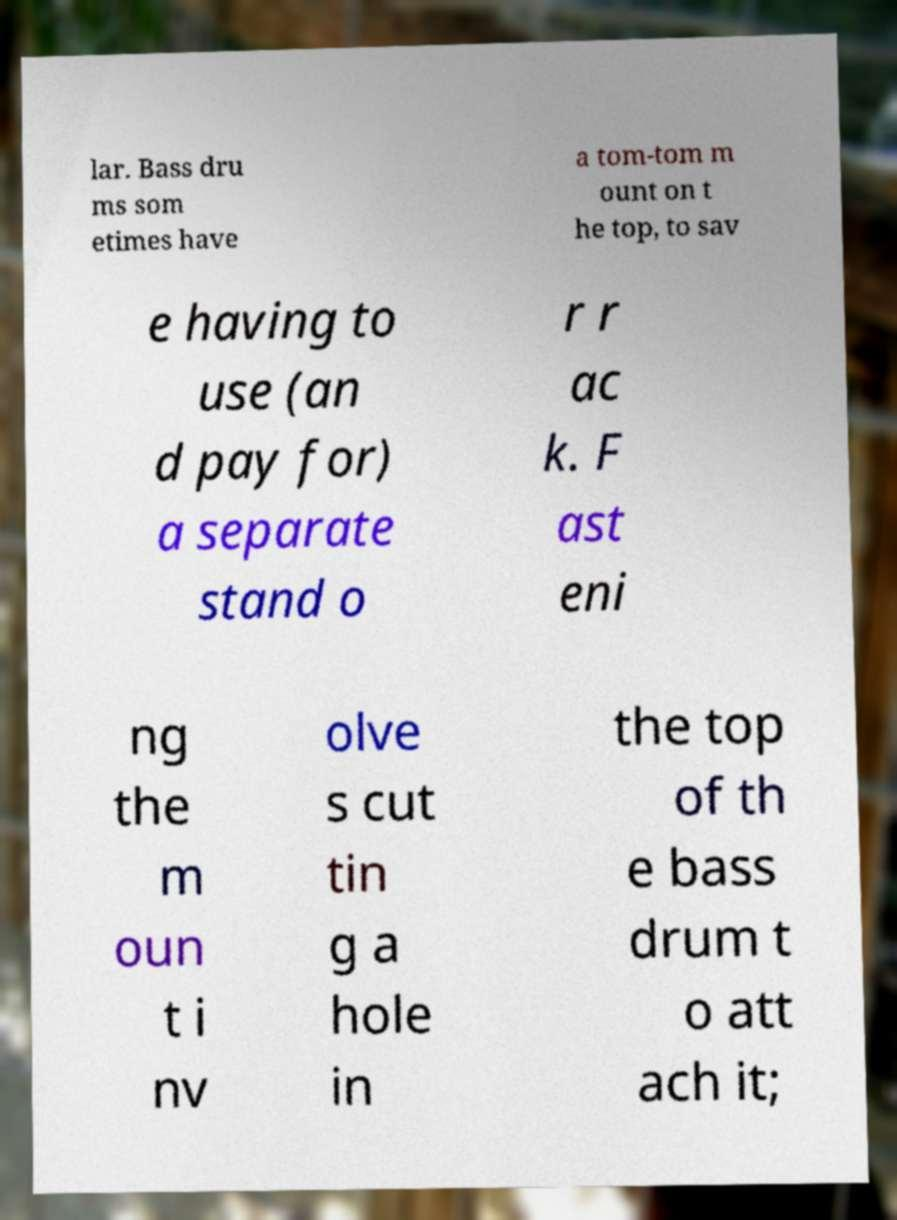What messages or text are displayed in this image? I need them in a readable, typed format. lar. Bass dru ms som etimes have a tom-tom m ount on t he top, to sav e having to use (an d pay for) a separate stand o r r ac k. F ast eni ng the m oun t i nv olve s cut tin g a hole in the top of th e bass drum t o att ach it; 